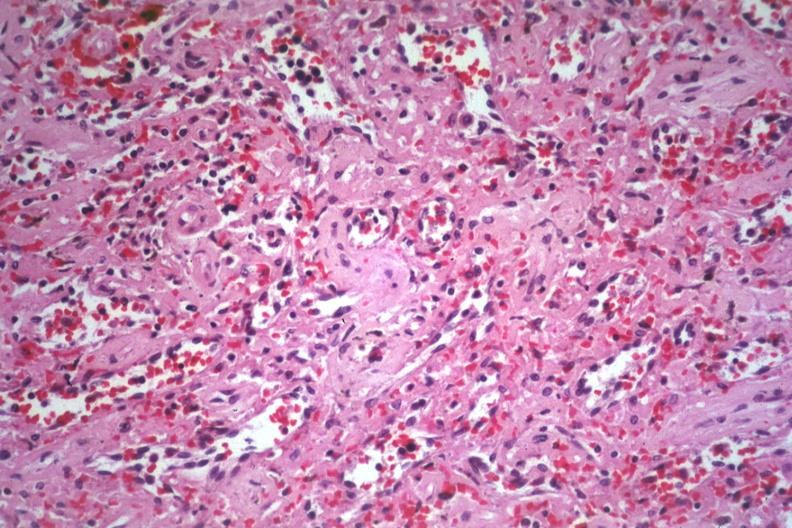what is present?
Answer the question using a single word or phrase. Hematologic 